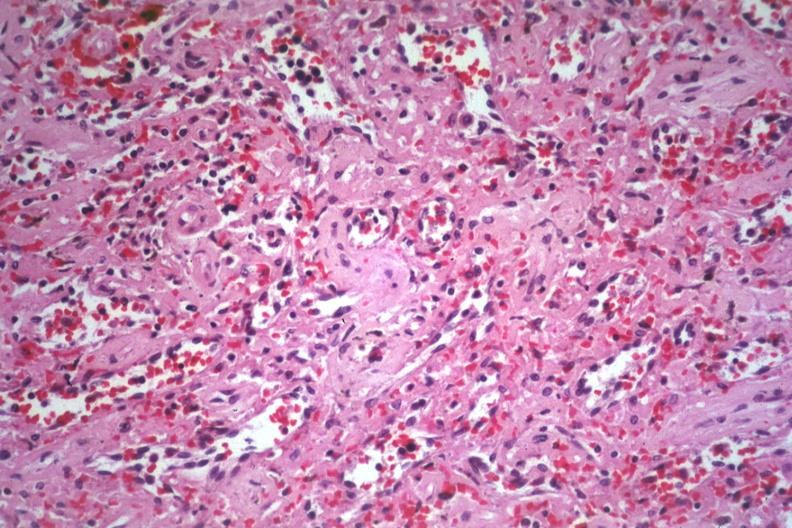what is present?
Answer the question using a single word or phrase. Hematologic 